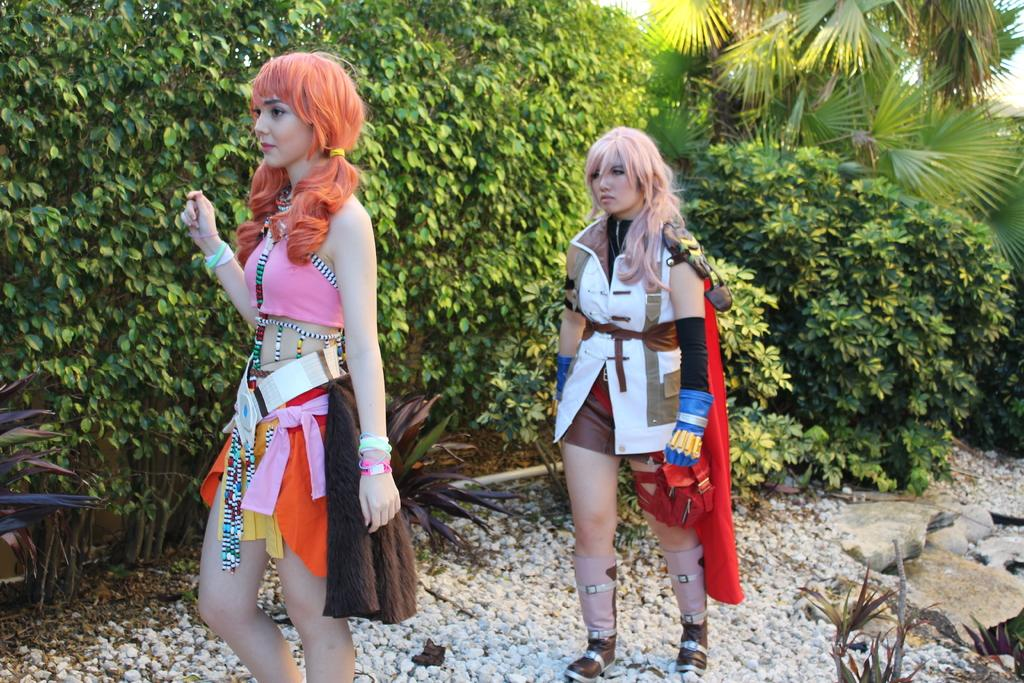How many girls are in the image? There are two girls standing in the image. What can be seen in the background of the image? There are trees visible in the background of the image. What is visible at the top of the image? The sky is visible at the top of the image. What type of terrain is at the bottom of the image? There are stones and plants at the bottom of the image. What object is present in the image? There is a pipe present in the image. What type of vessel is visible at the airport in the image? There is no vessel or airport present in the image. How many wheels can be seen on the vehicle in the image? There is no vehicle or wheel present in the image. 